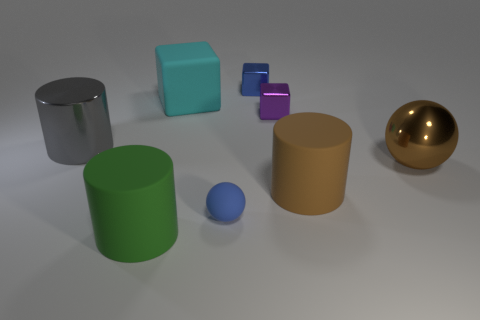What size is the gray thing that is the same shape as the green matte thing?
Offer a terse response. Large. Is there anything else that is the same material as the cyan cube?
Your answer should be very brief. Yes. Does the sphere left of the tiny purple block have the same size as the shiny block to the right of the blue shiny object?
Offer a terse response. Yes. What number of big objects are purple shiny blocks or yellow matte cylinders?
Your response must be concise. 0. What number of metal things are to the right of the big cyan object and behind the big ball?
Provide a short and direct response. 2. Are the large cyan object and the small thing in front of the big gray metallic cylinder made of the same material?
Offer a terse response. Yes. What number of brown objects are either small matte balls or metal spheres?
Provide a short and direct response. 1. Are there any blue things of the same size as the gray thing?
Ensure brevity in your answer.  No. What is the small object in front of the metal thing left of the large rubber cylinder to the left of the big cyan object made of?
Your response must be concise. Rubber. Are there the same number of blue balls behind the brown metal sphere and large blue shiny balls?
Provide a short and direct response. Yes. 